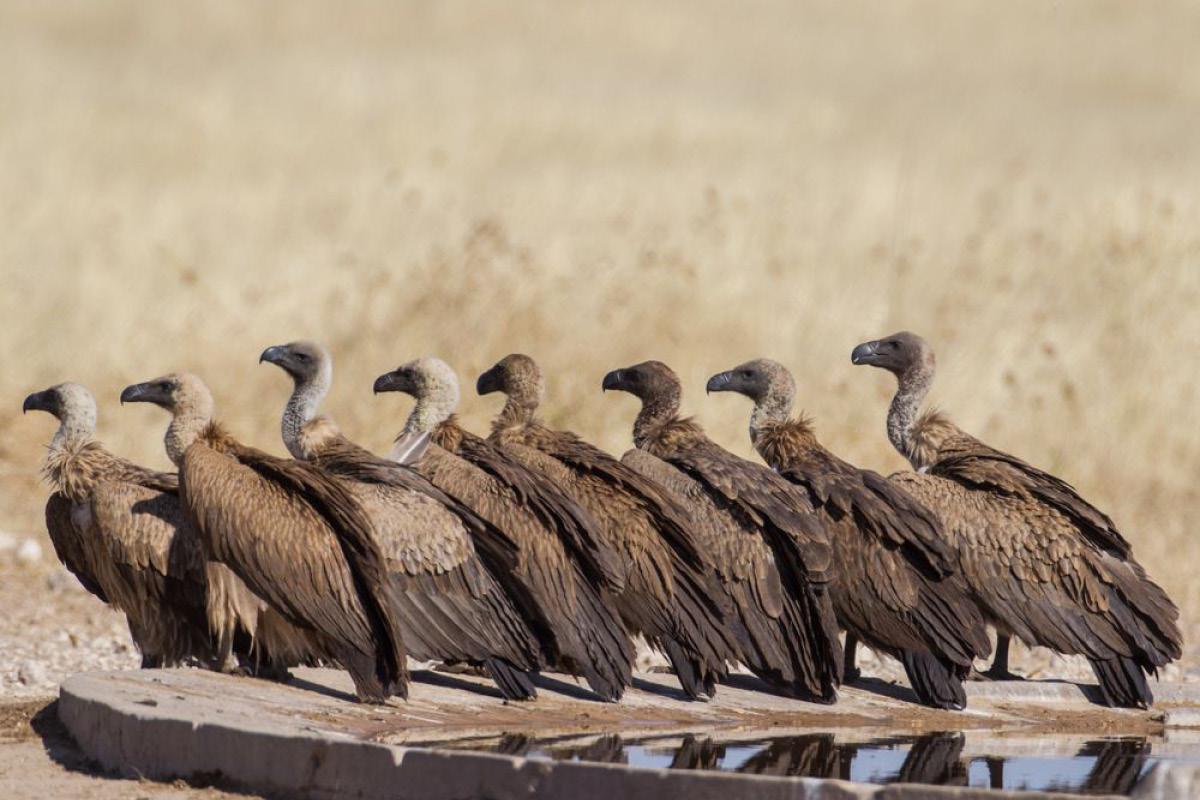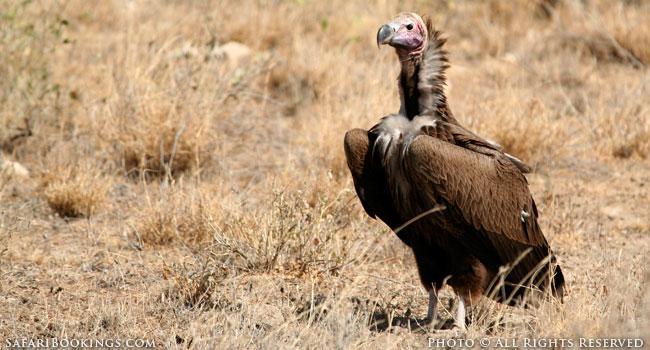The first image is the image on the left, the second image is the image on the right. Analyze the images presented: Is the assertion "One of the birds appears to have two heads in one of the images." valid? Answer yes or no. No. The first image is the image on the left, the second image is the image on the right. For the images shown, is this caption "Overlapping vultures face opposite directions in the center of one image, which has a brown background." true? Answer yes or no. No. 